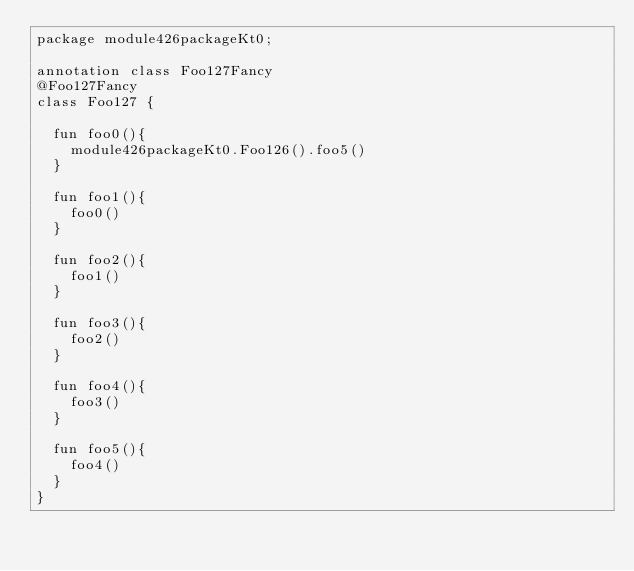<code> <loc_0><loc_0><loc_500><loc_500><_Kotlin_>package module426packageKt0;

annotation class Foo127Fancy
@Foo127Fancy
class Foo127 {

  fun foo0(){
    module426packageKt0.Foo126().foo5()
  }

  fun foo1(){
    foo0()
  }

  fun foo2(){
    foo1()
  }

  fun foo3(){
    foo2()
  }

  fun foo4(){
    foo3()
  }

  fun foo5(){
    foo4()
  }
}</code> 